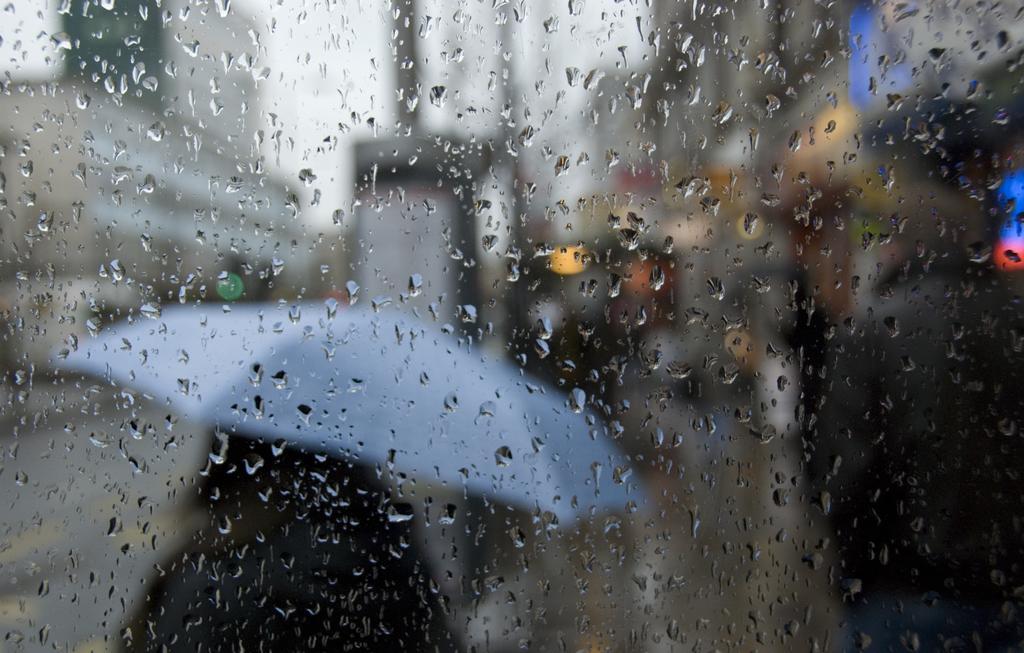Describe this image in one or two sentences. In this image I can see a glass. Background I can see an umbrella in lite blue color and sky in white color. 